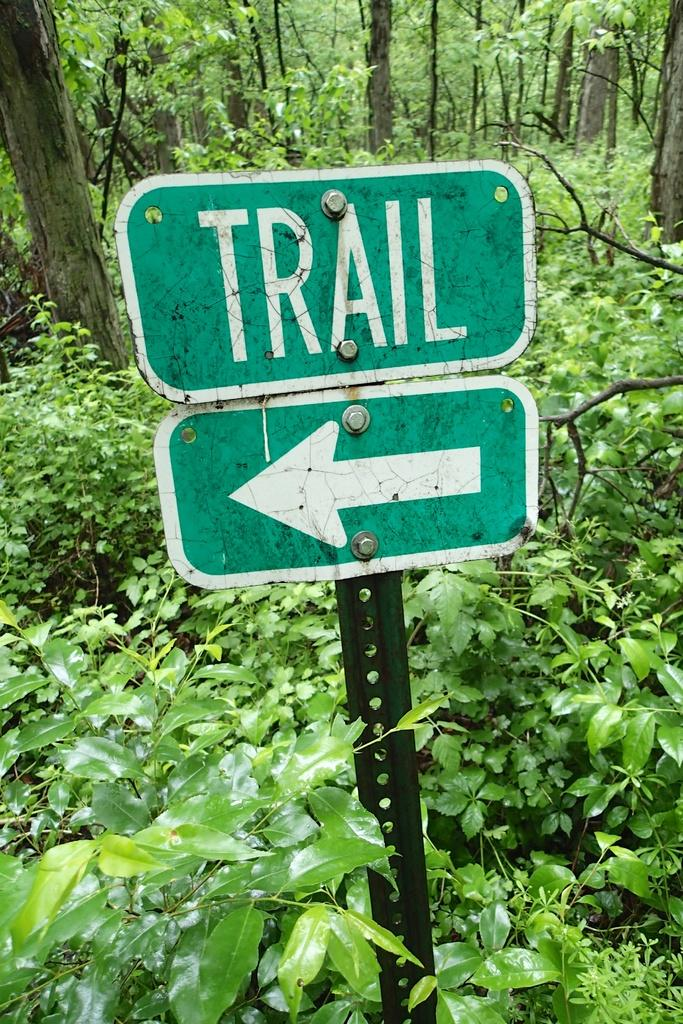<image>
Render a clear and concise summary of the photo. A green sign that points in the direction of a trail is surrounded by greenery in the outdoors. 